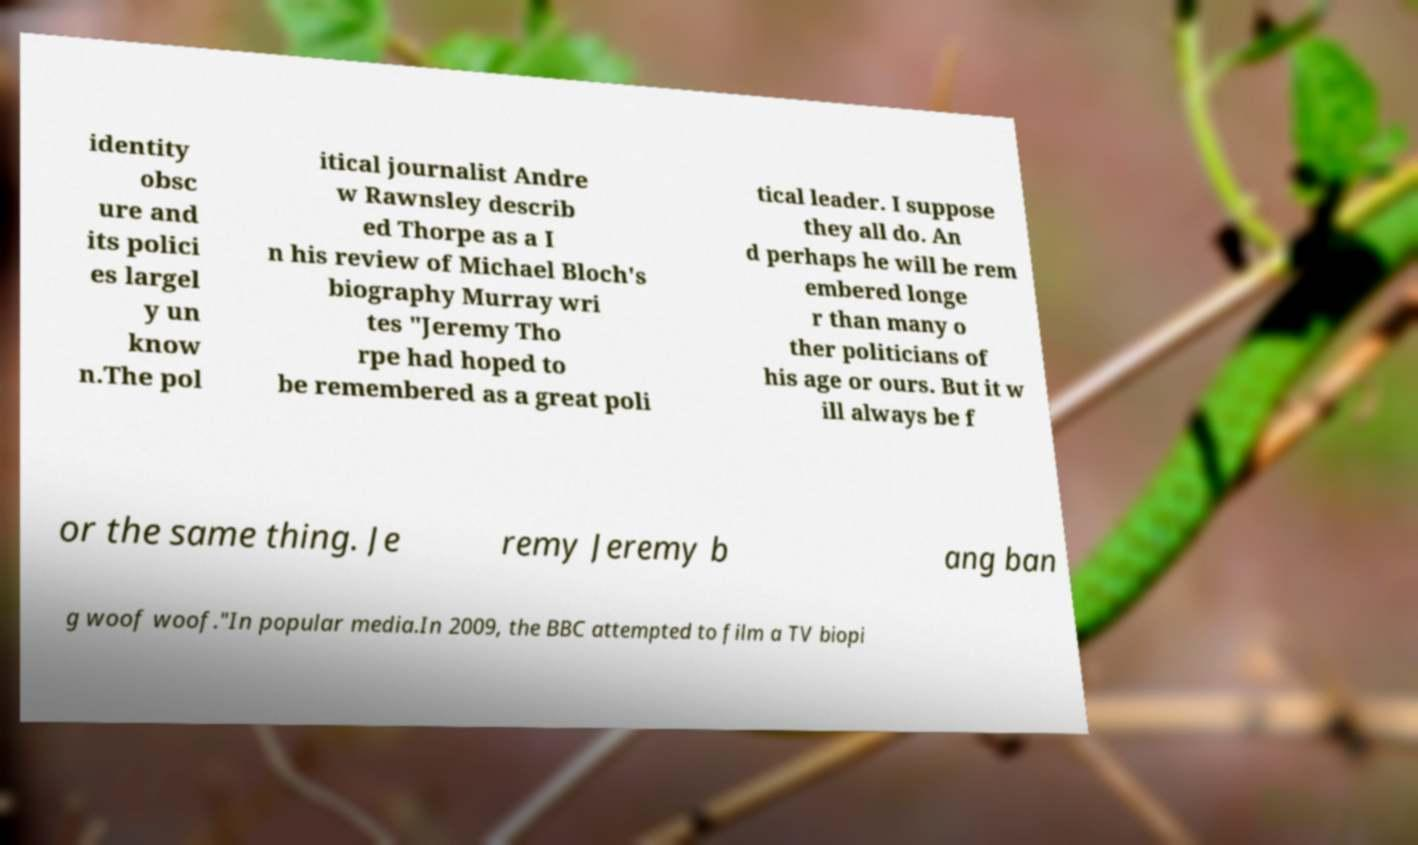There's text embedded in this image that I need extracted. Can you transcribe it verbatim? identity obsc ure and its polici es largel y un know n.The pol itical journalist Andre w Rawnsley describ ed Thorpe as a I n his review of Michael Bloch's biography Murray wri tes "Jeremy Tho rpe had hoped to be remembered as a great poli tical leader. I suppose they all do. An d perhaps he will be rem embered longe r than many o ther politicians of his age or ours. But it w ill always be f or the same thing. Je remy Jeremy b ang ban g woof woof."In popular media.In 2009, the BBC attempted to film a TV biopi 